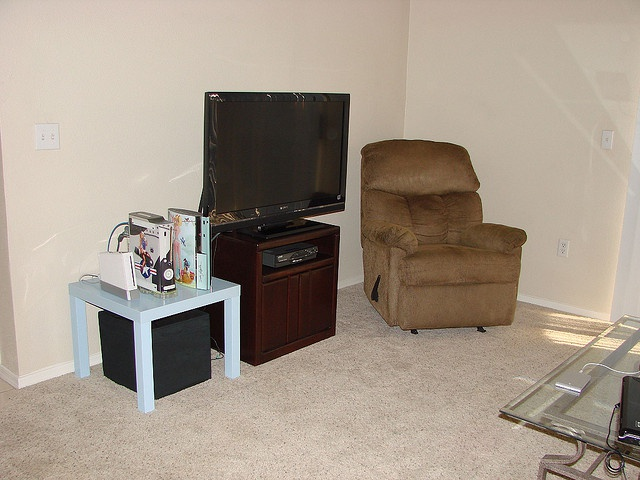Describe the objects in this image and their specific colors. I can see chair in darkgray, maroon, and gray tones, tv in darkgray, black, and gray tones, dining table in darkgray and gray tones, book in darkgray, lightgray, gray, and black tones, and book in darkgray, lightgray, lightblue, and gray tones in this image. 